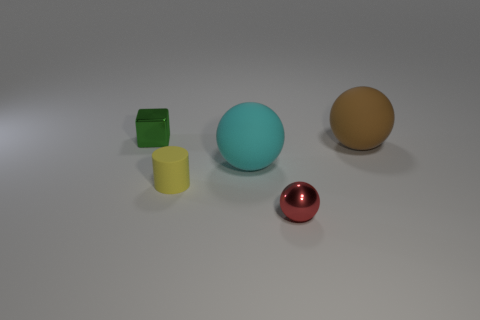Add 1 green metallic things. How many objects exist? 6 Subtract all balls. How many objects are left? 2 Subtract all brown metallic blocks. Subtract all red spheres. How many objects are left? 4 Add 1 big things. How many big things are left? 3 Add 2 red metal balls. How many red metal balls exist? 3 Subtract 0 cyan blocks. How many objects are left? 5 